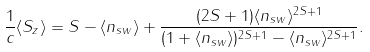Convert formula to latex. <formula><loc_0><loc_0><loc_500><loc_500>\frac { 1 } { c } \langle S _ { z } \rangle = S - \langle n _ { s w } \rangle + \frac { ( 2 S + 1 ) \langle n _ { s w } \rangle ^ { 2 S + 1 } } { ( 1 + \langle n _ { s w } \rangle ) ^ { 2 S + 1 } - \langle n _ { s w } \rangle ^ { 2 S + 1 } } .</formula> 